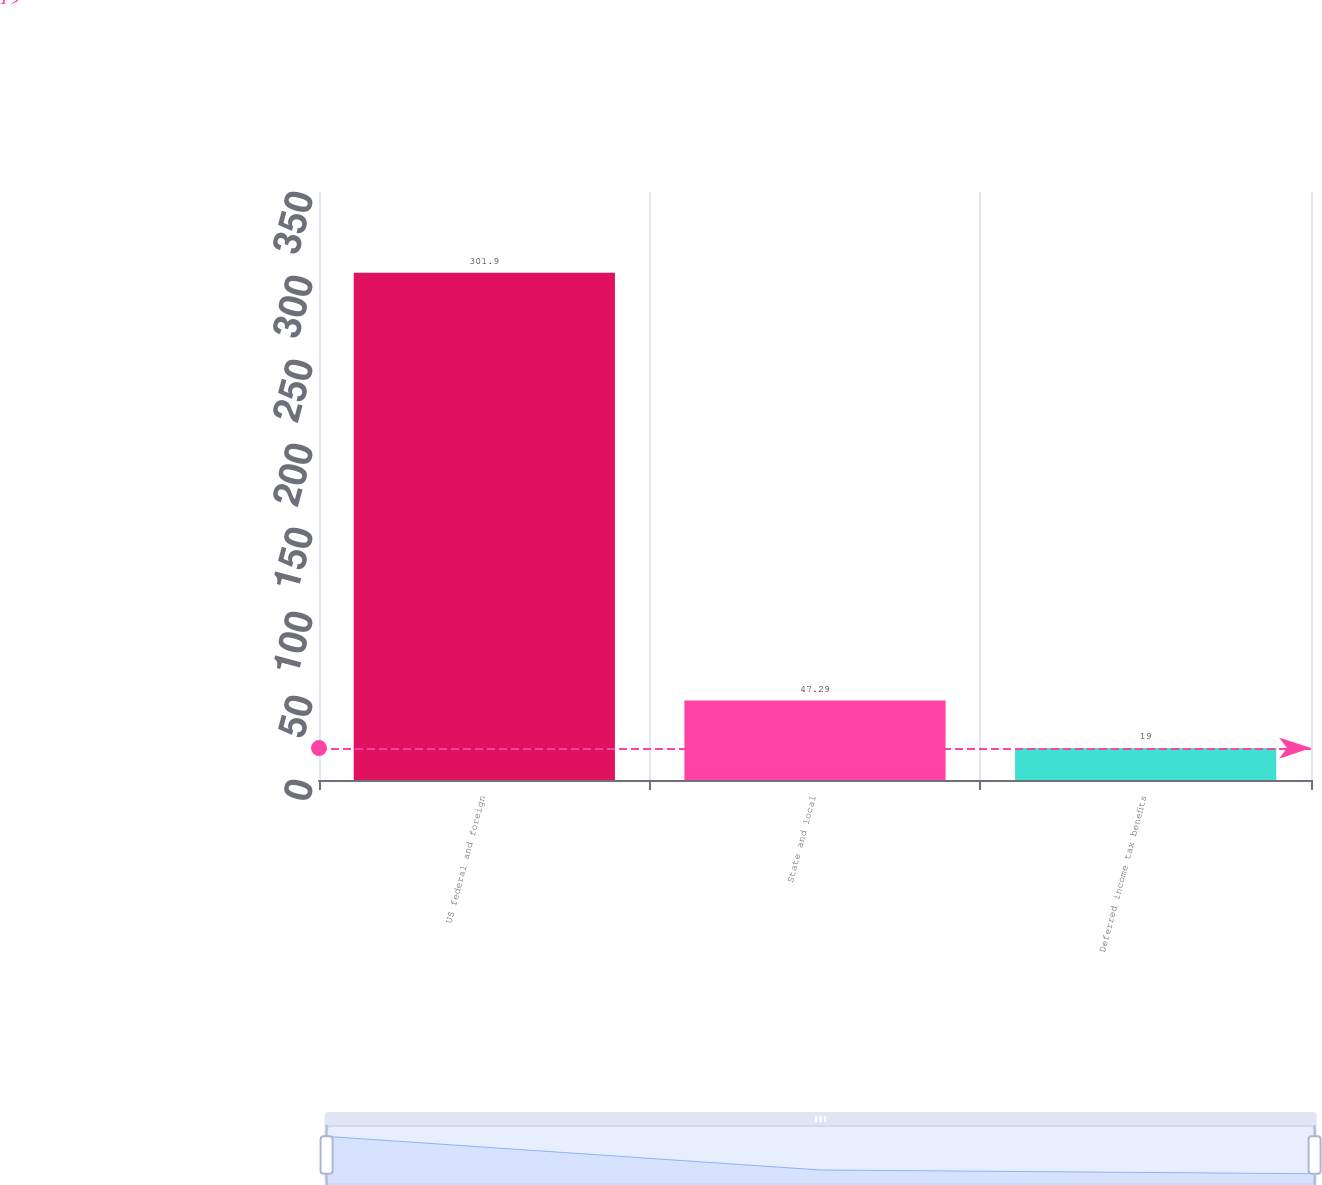Convert chart to OTSL. <chart><loc_0><loc_0><loc_500><loc_500><bar_chart><fcel>US federal and foreign<fcel>State and local<fcel>Deferred income tax benefits<nl><fcel>301.9<fcel>47.29<fcel>19<nl></chart> 